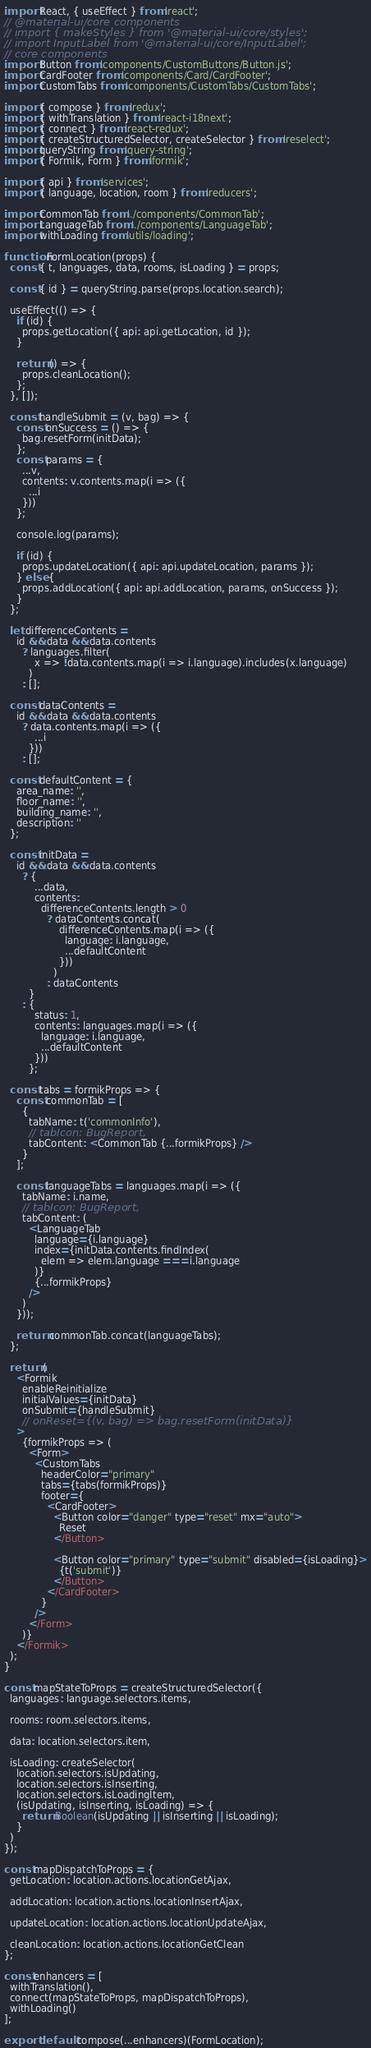<code> <loc_0><loc_0><loc_500><loc_500><_JavaScript_>import React, { useEffect } from 'react';
// @material-ui/core components
// import { makeStyles } from '@material-ui/core/styles';
// import InputLabel from '@material-ui/core/InputLabel';
// core components
import Button from 'components/CustomButtons/Button.js';
import CardFooter from 'components/Card/CardFooter';
import CustomTabs from 'components/CustomTabs/CustomTabs';

import { compose } from 'redux';
import { withTranslation } from 'react-i18next';
import { connect } from 'react-redux';
import { createStructuredSelector, createSelector } from 'reselect';
import queryString from 'query-string';
import { Formik, Form } from 'formik';

import { api } from 'services';
import { language, location, room } from 'reducers';

import CommonTab from './components/CommonTab';
import LanguageTab from './components/LanguageTab';
import withLoading from 'utils/loading';

function FormLocation(props) {
  const { t, languages, data, rooms, isLoading } = props;

  const { id } = queryString.parse(props.location.search);

  useEffect(() => {
    if (id) {
      props.getLocation({ api: api.getLocation, id });
    }

    return () => {
      props.cleanLocation();
    };
  }, []);

  const handleSubmit = (v, bag) => {
    const onSuccess = () => {
      bag.resetForm(initData);
    };
    const params = {
      ...v,
      contents: v.contents.map(i => ({
        ...i
      }))
    };

    console.log(params);

    if (id) {
      props.updateLocation({ api: api.updateLocation, params });
    } else {
      props.addLocation({ api: api.addLocation, params, onSuccess });
    }
  };

  let differenceContents =
    id && data && data.contents
      ? languages.filter(
          x => !data.contents.map(i => i.language).includes(x.language)
        )
      : [];

  const dataContents =
    id && data && data.contents
      ? data.contents.map(i => ({
          ...i
        }))
      : [];

  const defaultContent = {
    area_name: '',
    floor_name: '',
    building_name: '',
    description: ''
  };

  const initData =
    id && data && data.contents
      ? {
          ...data,
          contents:
            differenceContents.length > 0
              ? dataContents.concat(
                  differenceContents.map(i => ({
                    language: i.language,
                    ...defaultContent
                  }))
                )
              : dataContents
        }
      : {
          status: 1,
          contents: languages.map(i => ({
            language: i.language,
            ...defaultContent
          }))
        };

  const tabs = formikProps => {
    const commonTab = [
      {
        tabName: t('commonInfo'),
        // tabIcon: BugReport,
        tabContent: <CommonTab {...formikProps} />
      }
    ];

    const languageTabs = languages.map(i => ({
      tabName: i.name,
      // tabIcon: BugReport,
      tabContent: (
        <LanguageTab
          language={i.language}
          index={initData.contents.findIndex(
            elem => elem.language === i.language
          )}
          {...formikProps}
        />
      )
    }));

    return commonTab.concat(languageTabs);
  };

  return (
    <Formik
      enableReinitialize
      initialValues={initData}
      onSubmit={handleSubmit}
      // onReset={(v, bag) => bag.resetForm(initData)}
    >
      {formikProps => (
        <Form>
          <CustomTabs
            headerColor="primary"
            tabs={tabs(formikProps)}
            footer={
              <CardFooter>
                <Button color="danger" type="reset" mx="auto">
                  Reset
                </Button>

                <Button color="primary" type="submit" disabled={isLoading}>
                  {t('submit')}
                </Button>
              </CardFooter>
            }
          />
        </Form>
      )}
    </Formik>
  );
}

const mapStateToProps = createStructuredSelector({
  languages: language.selectors.items,

  rooms: room.selectors.items,

  data: location.selectors.item,

  isLoading: createSelector(
    location.selectors.isUpdating,
    location.selectors.isInserting,
    location.selectors.isLoadingItem,
    (isUpdating, isInserting, isLoading) => {
      return Boolean(isUpdating || isInserting || isLoading);
    }
  )
});

const mapDispatchToProps = {
  getLocation: location.actions.locationGetAjax,

  addLocation: location.actions.locationInsertAjax,

  updateLocation: location.actions.locationUpdateAjax,

  cleanLocation: location.actions.locationGetClean
};

const enhancers = [
  withTranslation(),
  connect(mapStateToProps, mapDispatchToProps),
  withLoading()
];

export default compose(...enhancers)(FormLocation);
</code> 